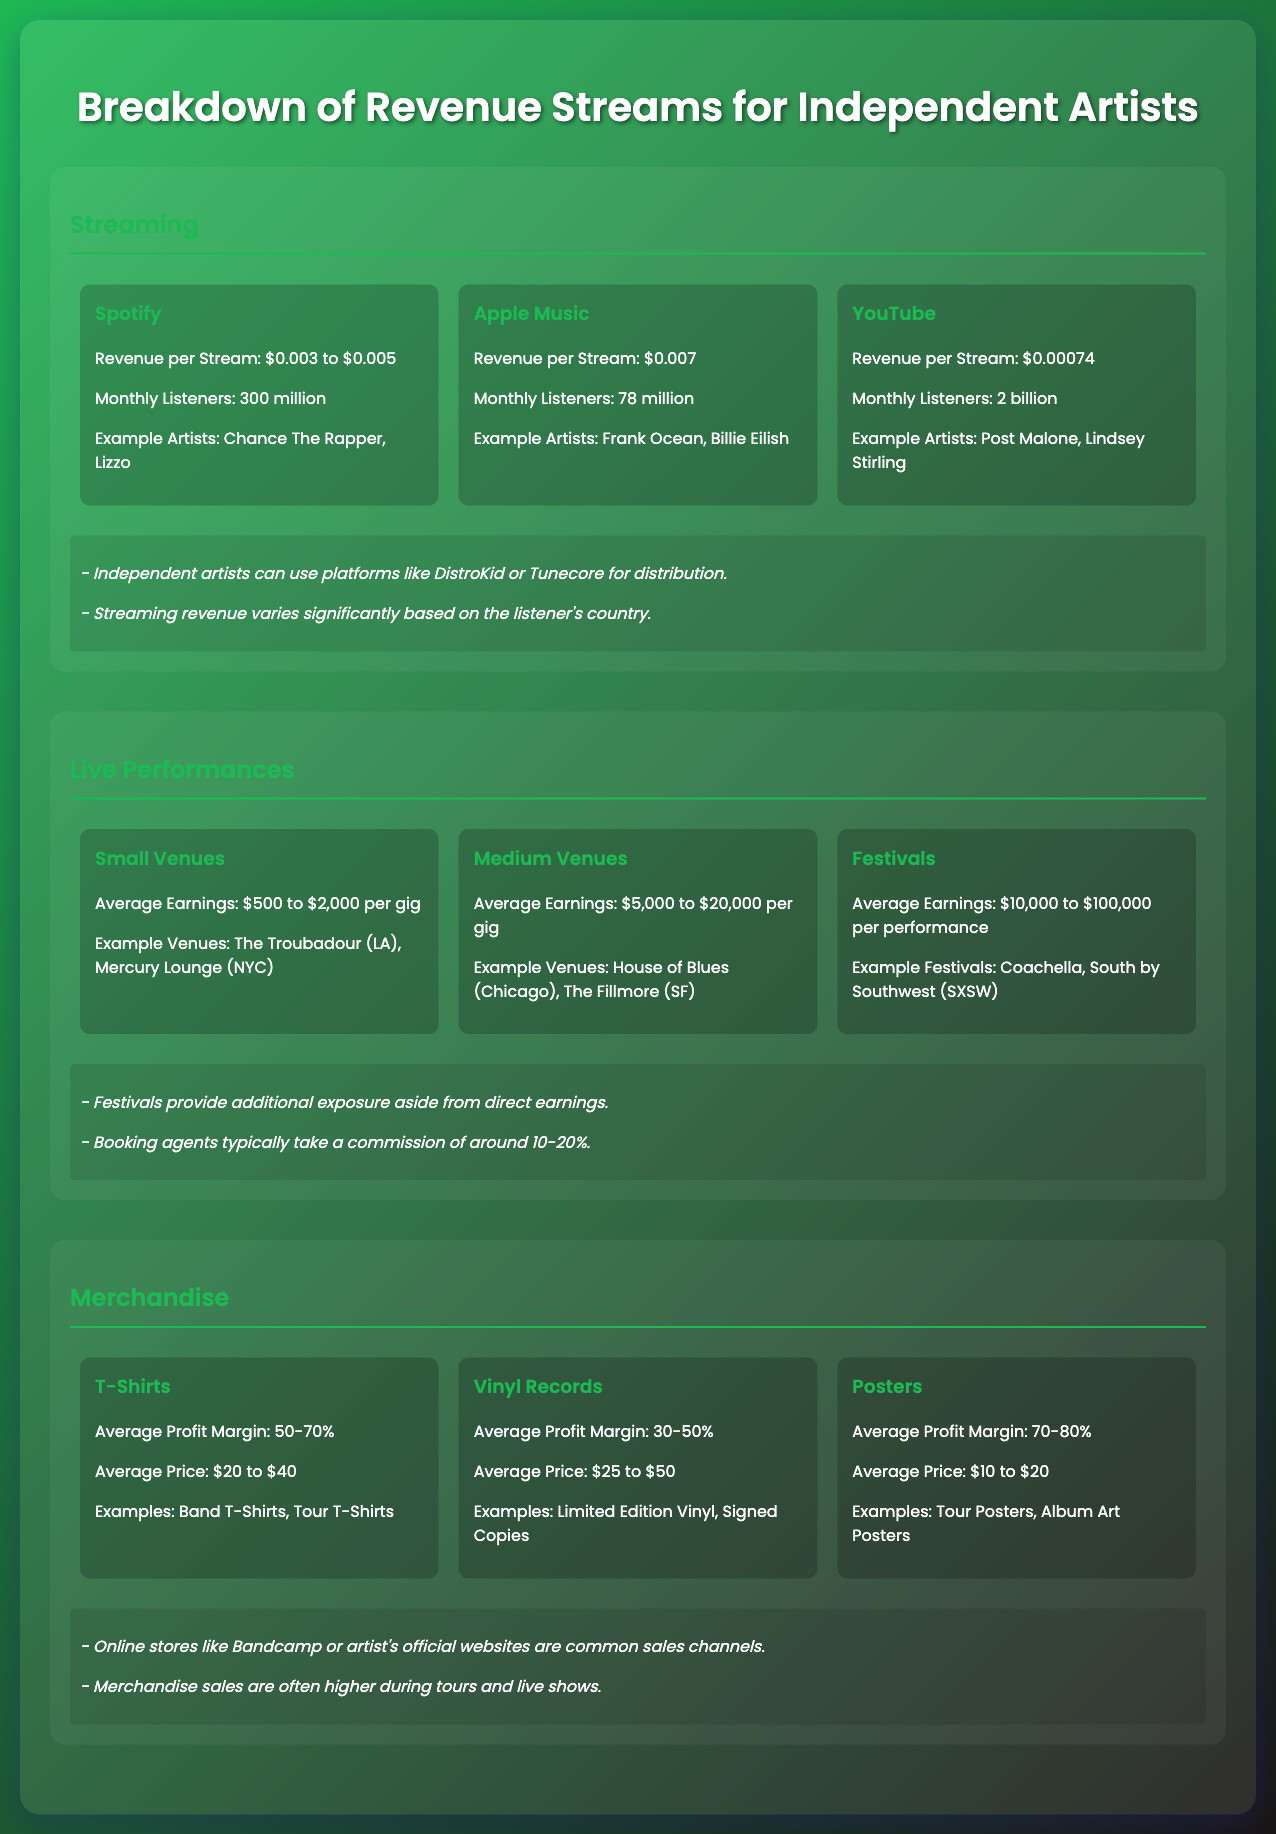What is the revenue per stream on Spotify? The revenue per stream on Spotify is between $0.003 to $0.005 as stated in the document.
Answer: $0.003 to $0.005 What is the average profit margin for T-Shirts? The average profit margin for T-Shirts is listed as 50-70% in the merchandise section.
Answer: 50-70% How much can independent artists earn on average for a gig at small venues? The document states that artists can earn between $500 to $2,000 per gig at small venues.
Answer: $500 to $2,000 Which platform has the highest revenue per stream? The platform with the highest revenue per stream mentioned in the document is Apple Music, at $0.007.
Answer: Apple Music What is one example of a festival mentioned in the infographic? One example of a festival mentioned is Coachella.
Answer: Coachella How many monthly listeners does YouTube have? The document indicates that YouTube has 2 billion monthly listeners.
Answer: 2 billion What is the average price range for vinyl records? The average price for vinyl records is stated to be between $25 to $50.
Answer: $25 to $50 Which merchandise item has the highest average profit margin? The document indicates that posters have the highest average profit margin at 70-80%.
Answer: Posters What is a common sales channel for merchandise? The document mentions that online stores like Bandcamp or the artist's official websites are common sales channels.
Answer: Bandcamp 